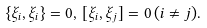<formula> <loc_0><loc_0><loc_500><loc_500>\{ \xi _ { i } , \xi _ { i } \} = 0 , \, [ \xi _ { i } , \xi _ { j } ] = 0 \, ( i \neq j ) .</formula> 